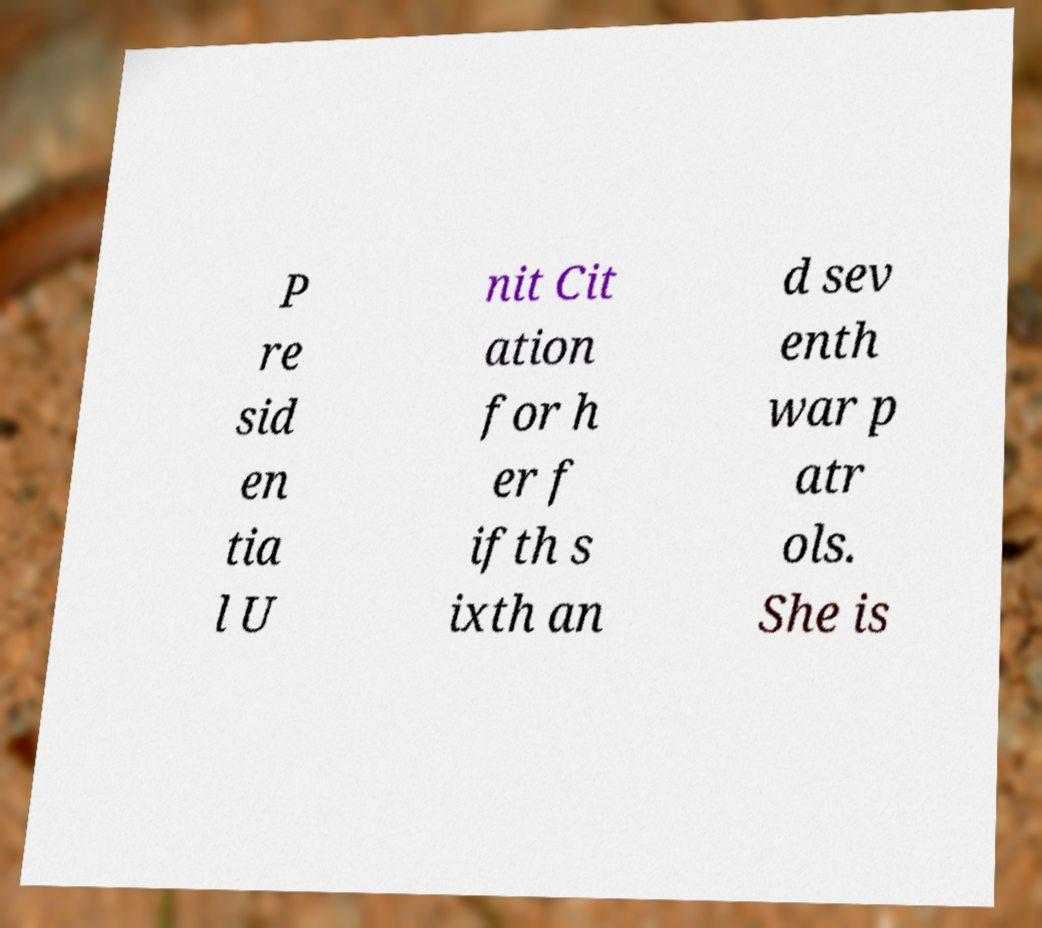Could you extract and type out the text from this image? P re sid en tia l U nit Cit ation for h er f ifth s ixth an d sev enth war p atr ols. She is 